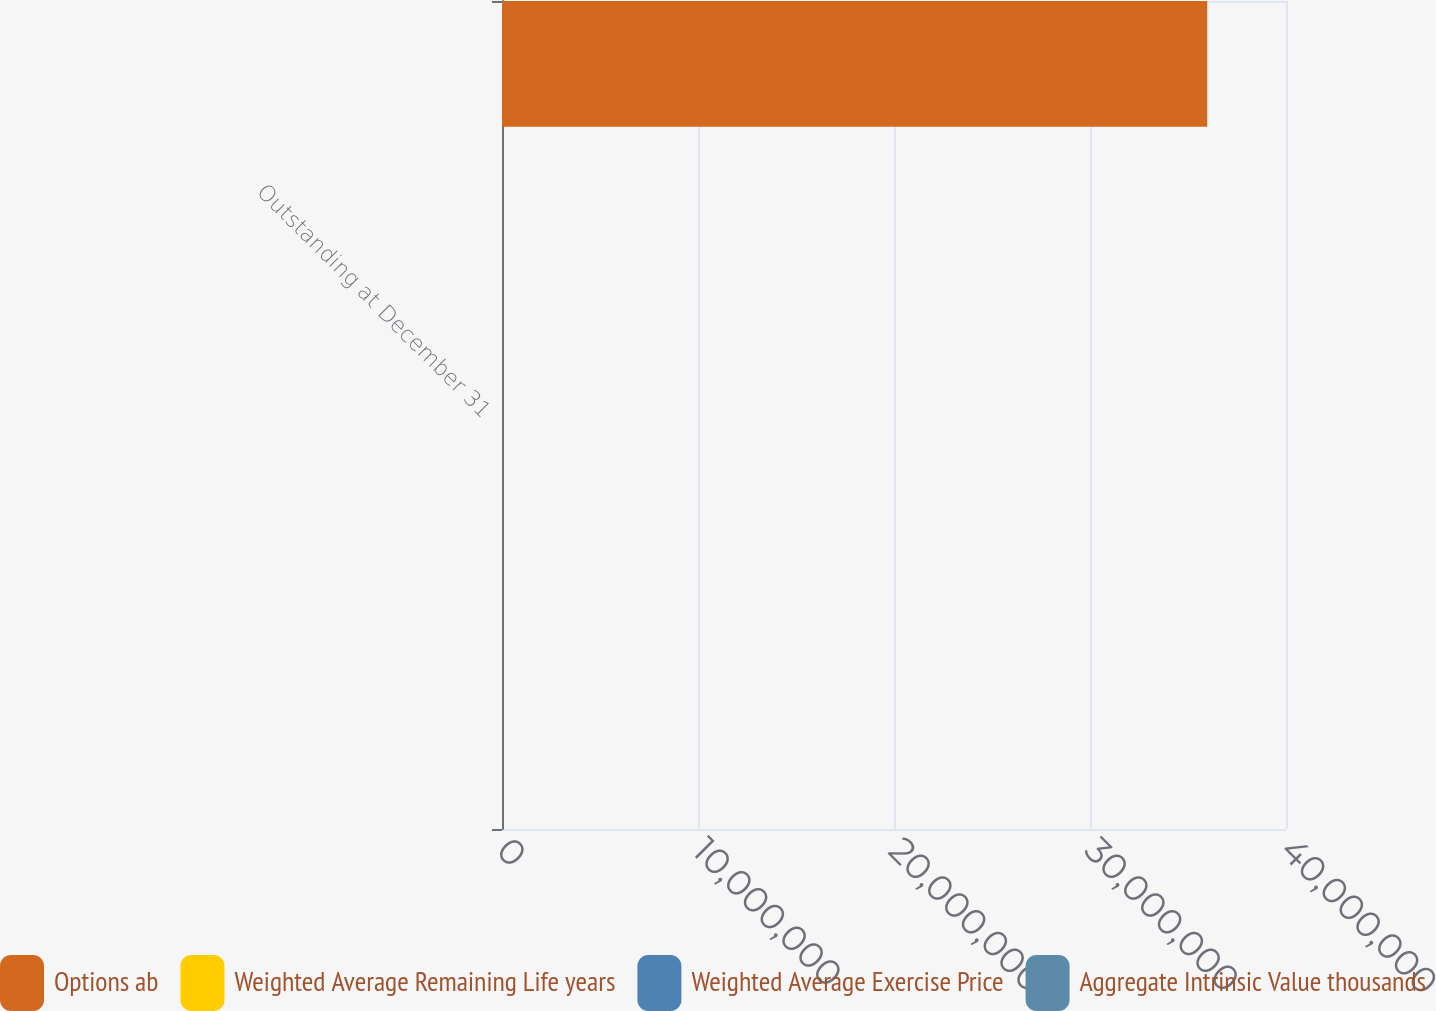<chart> <loc_0><loc_0><loc_500><loc_500><stacked_bar_chart><ecel><fcel>Outstanding at December 31<nl><fcel>Options ab<fcel>3.59827e+07<nl><fcel>Weighted Average Remaining Life years<fcel>39.52<nl><fcel>Weighted Average Exercise Price<fcel>5.08<nl><fcel>Aggregate Intrinsic Value thousands<fcel>1422<nl></chart> 